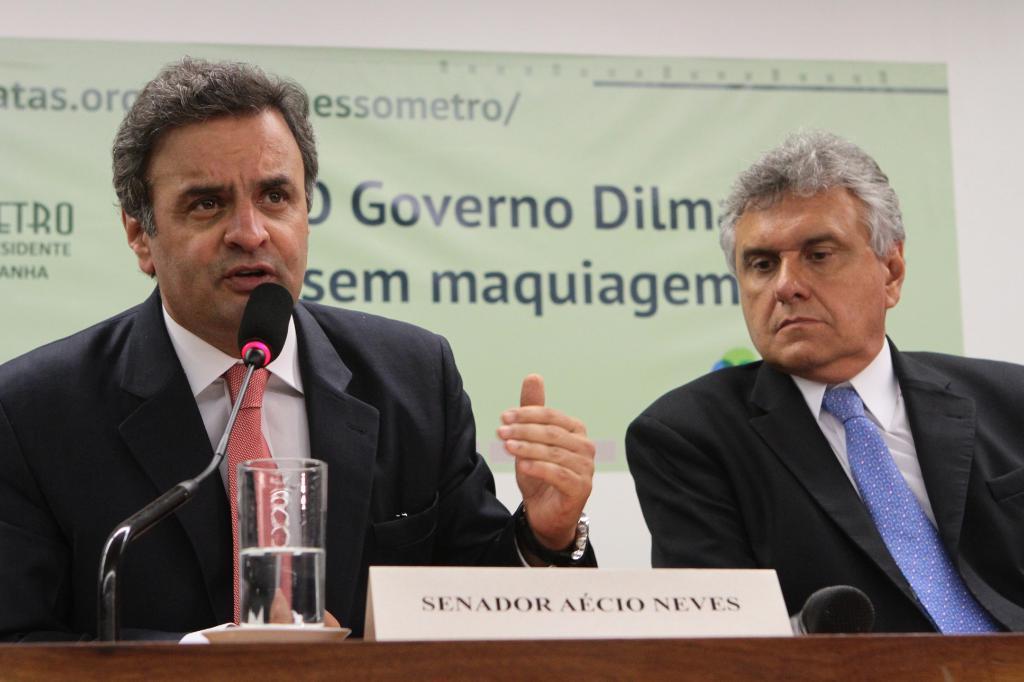Can you describe this image briefly? The man in the left corner of the picture wearing white shirt and black blazer is talking on the microphone. Beside him, the man in white shirt and black blazer is sitting on the chair. In front of them, we see a table on which a glass containing water, microphone and a name board are placed. Behind them, we see a green banner with some text written on it. This picture is clicked in the conference hall. 